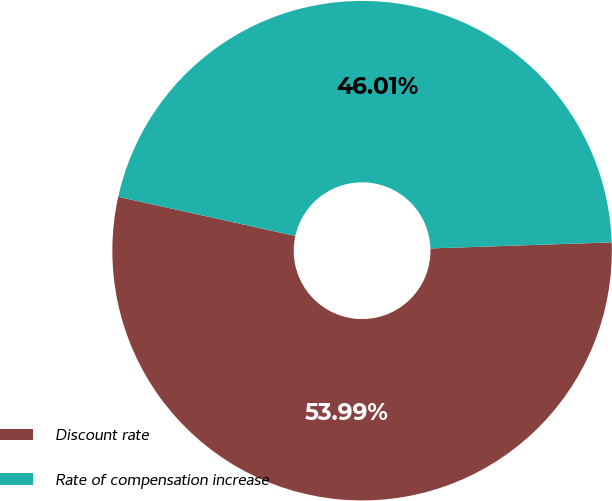<chart> <loc_0><loc_0><loc_500><loc_500><pie_chart><fcel>Discount rate<fcel>Rate of compensation increase<nl><fcel>53.99%<fcel>46.01%<nl></chart> 